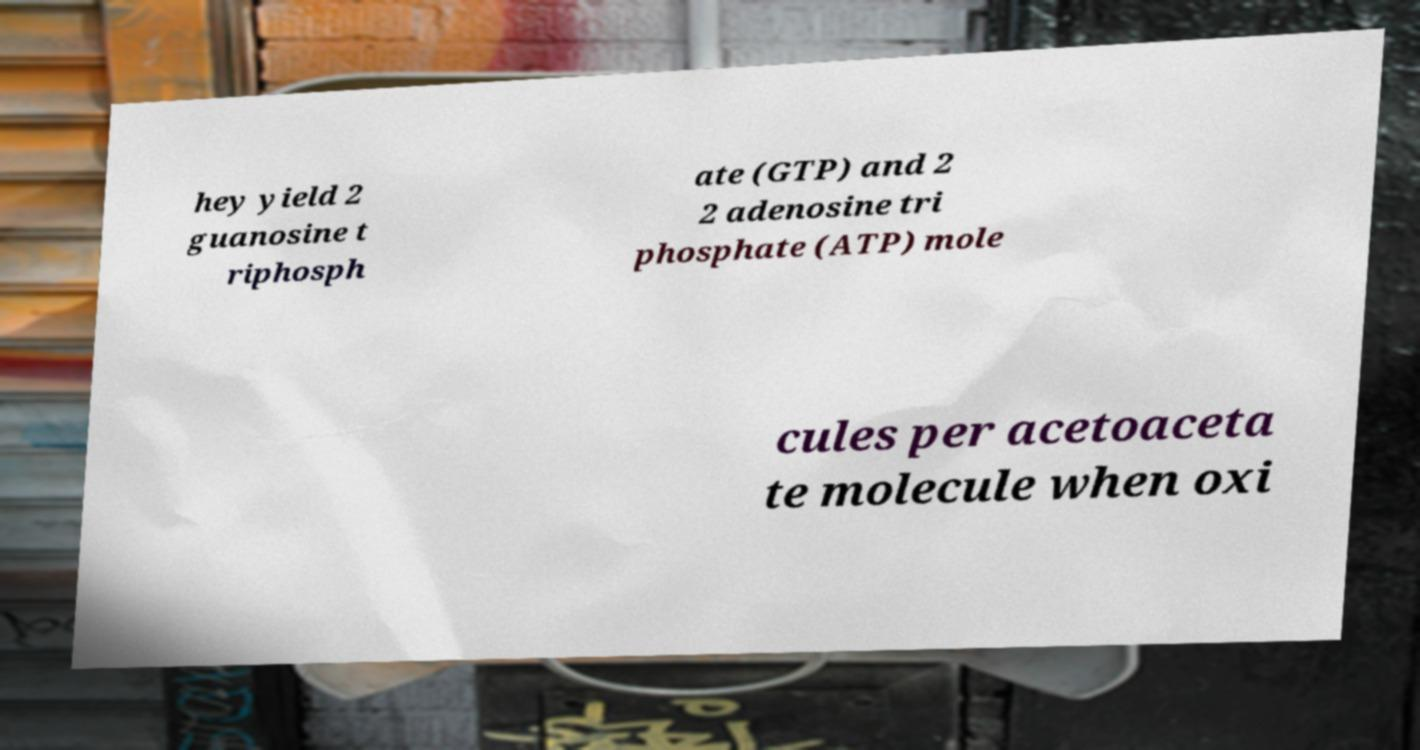Please identify and transcribe the text found in this image. hey yield 2 guanosine t riphosph ate (GTP) and 2 2 adenosine tri phosphate (ATP) mole cules per acetoaceta te molecule when oxi 